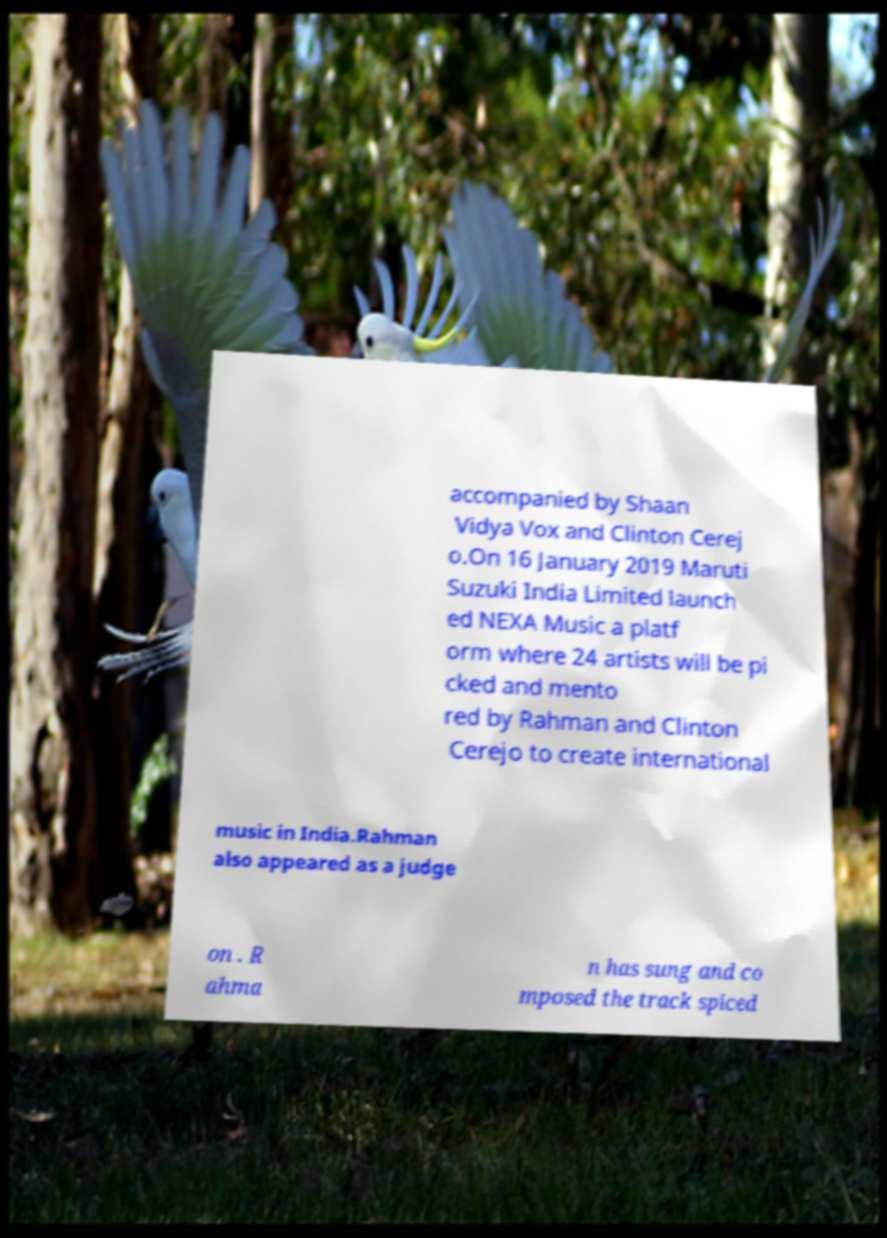There's text embedded in this image that I need extracted. Can you transcribe it verbatim? accompanied by Shaan Vidya Vox and Clinton Cerej o.On 16 January 2019 Maruti Suzuki India Limited launch ed NEXA Music a platf orm where 24 artists will be pi cked and mento red by Rahman and Clinton Cerejo to create international music in India.Rahman also appeared as a judge on . R ahma n has sung and co mposed the track spiced 